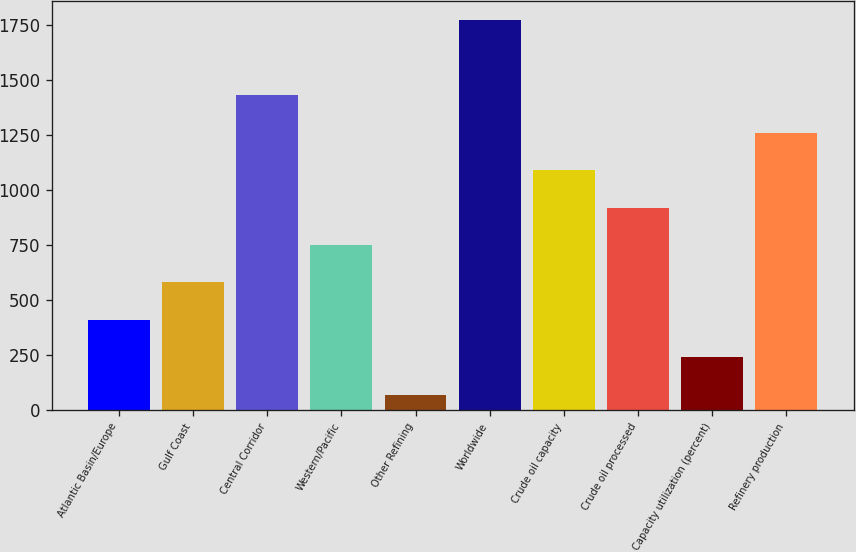<chart> <loc_0><loc_0><loc_500><loc_500><bar_chart><fcel>Atlantic Basin/Europe<fcel>Gulf Coast<fcel>Central Corridor<fcel>Western/Pacific<fcel>Other Refining<fcel>Worldwide<fcel>Crude oil capacity<fcel>Crude oil processed<fcel>Capacity utilization (percent)<fcel>Refinery production<nl><fcel>410.2<fcel>580.3<fcel>1430.8<fcel>750.4<fcel>70<fcel>1771<fcel>1090.6<fcel>920.5<fcel>240.1<fcel>1260.7<nl></chart> 